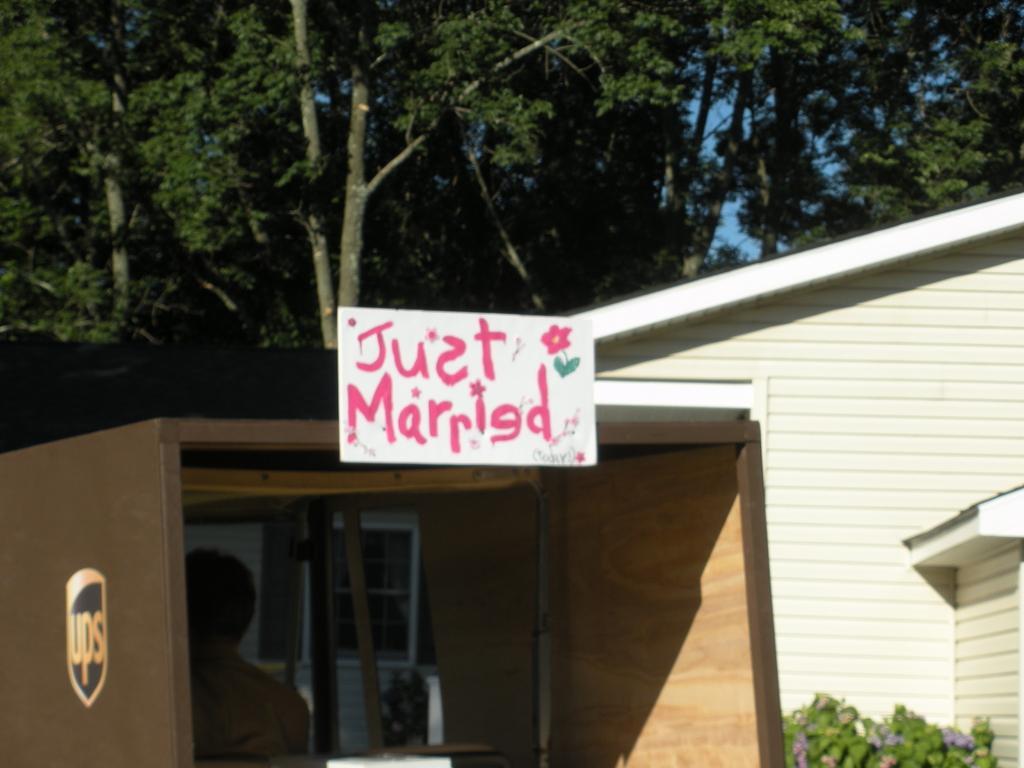How would you summarize this image in a sentence or two? In this picture we can see a text and an image of a flower on a white board. This board is on a wooden object. We can see a person and few things in the wooden object. There is a logo visible on this wooden object. We can see some plants on the right side. There is a house and a few trees visible in the background. Sky is blue in color. 